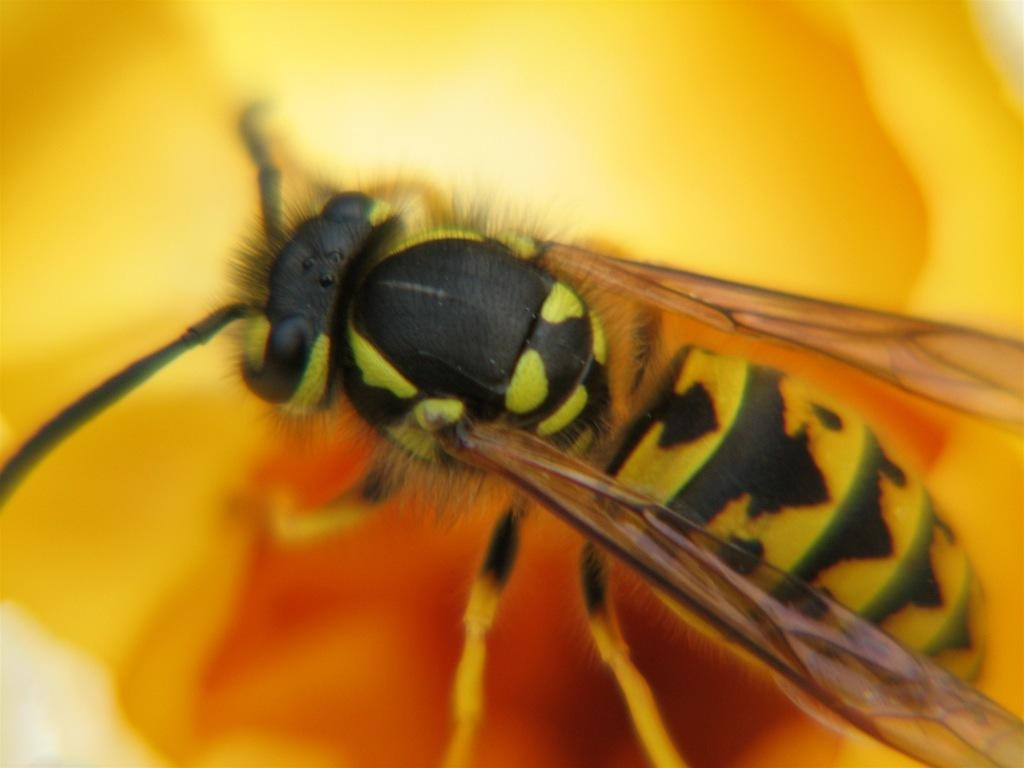What type of insect is present in the image? There is a fly in the image. How many cows can be seen grazing in the image? There are no cows present in the image; it only features a fly. What type of insect is shown performing tricks on a skateboard in the image? There is no insect performing tricks on a skateboard in the image; it only features a fly. 